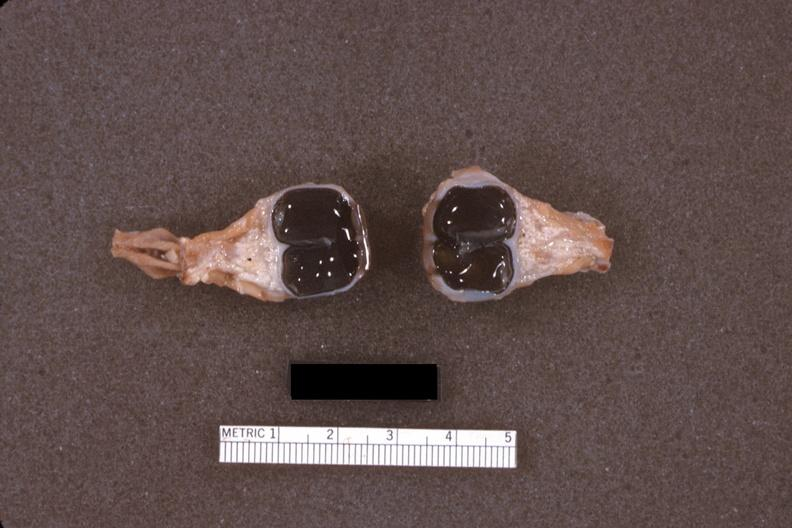does this image show fixed tissue dissected eyes?
Answer the question using a single word or phrase. Yes 